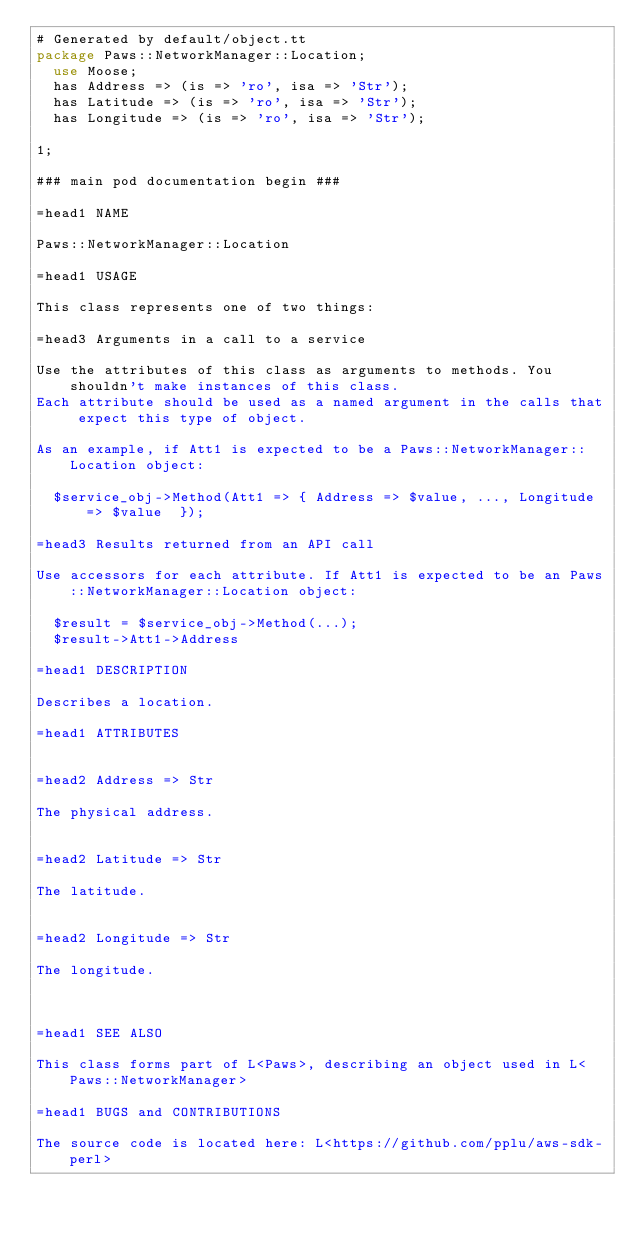Convert code to text. <code><loc_0><loc_0><loc_500><loc_500><_Perl_># Generated by default/object.tt
package Paws::NetworkManager::Location;
  use Moose;
  has Address => (is => 'ro', isa => 'Str');
  has Latitude => (is => 'ro', isa => 'Str');
  has Longitude => (is => 'ro', isa => 'Str');

1;

### main pod documentation begin ###

=head1 NAME

Paws::NetworkManager::Location

=head1 USAGE

This class represents one of two things:

=head3 Arguments in a call to a service

Use the attributes of this class as arguments to methods. You shouldn't make instances of this class. 
Each attribute should be used as a named argument in the calls that expect this type of object.

As an example, if Att1 is expected to be a Paws::NetworkManager::Location object:

  $service_obj->Method(Att1 => { Address => $value, ..., Longitude => $value  });

=head3 Results returned from an API call

Use accessors for each attribute. If Att1 is expected to be an Paws::NetworkManager::Location object:

  $result = $service_obj->Method(...);
  $result->Att1->Address

=head1 DESCRIPTION

Describes a location.

=head1 ATTRIBUTES


=head2 Address => Str

The physical address.


=head2 Latitude => Str

The latitude.


=head2 Longitude => Str

The longitude.



=head1 SEE ALSO

This class forms part of L<Paws>, describing an object used in L<Paws::NetworkManager>

=head1 BUGS and CONTRIBUTIONS

The source code is located here: L<https://github.com/pplu/aws-sdk-perl>
</code> 